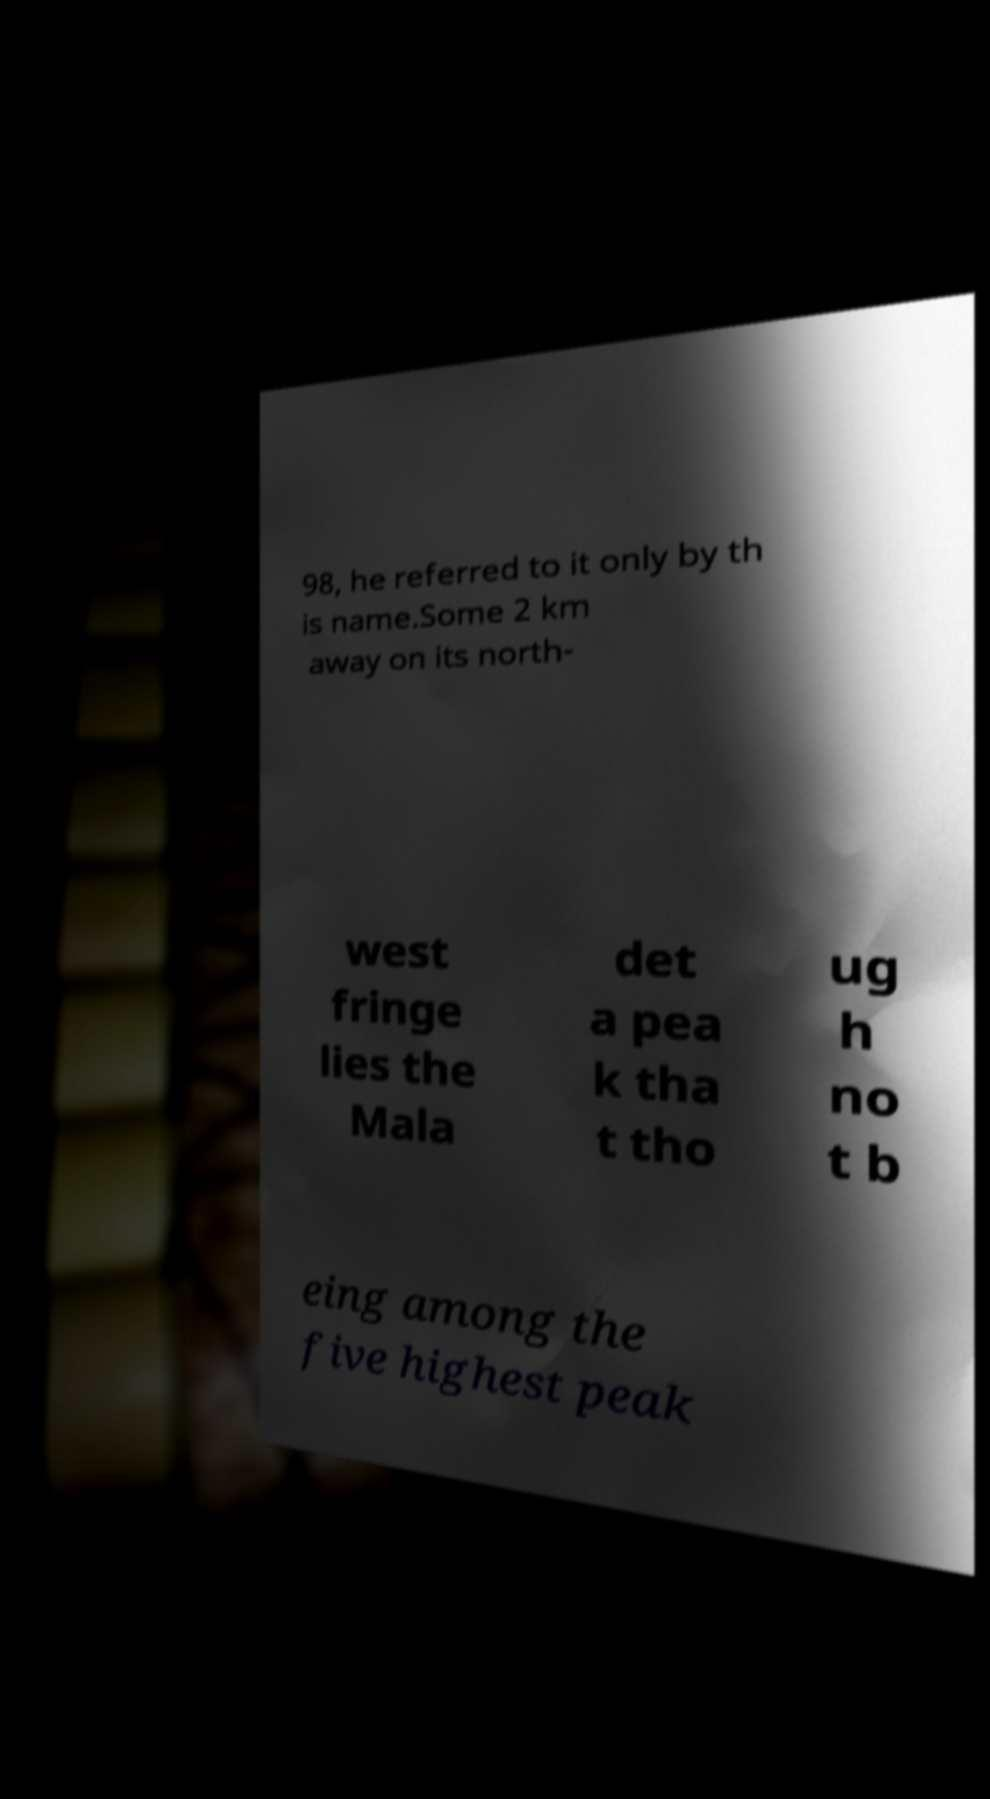Can you accurately transcribe the text from the provided image for me? 98, he referred to it only by th is name.Some 2 km away on its north- west fringe lies the Mala det a pea k tha t tho ug h no t b eing among the five highest peak 